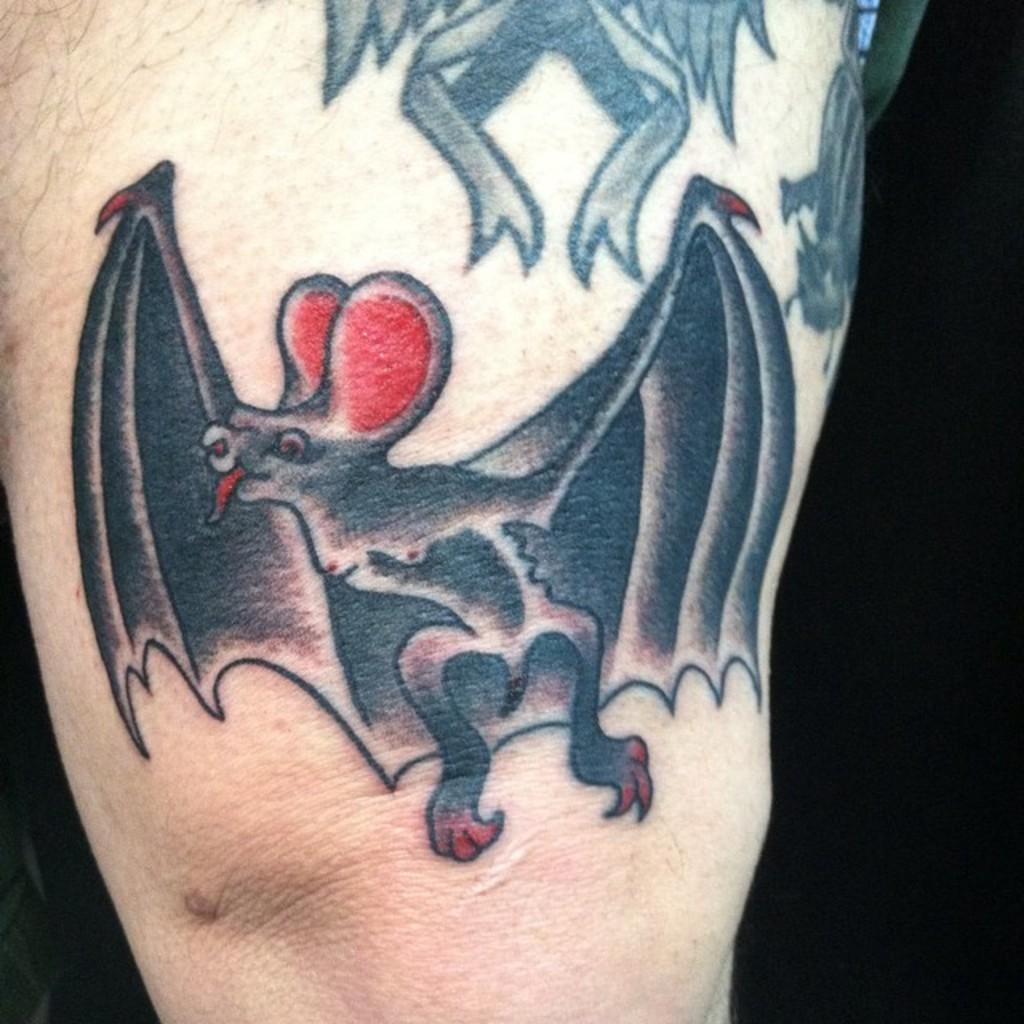What can be seen on the person's hand in the image? There is a tattoo on a person's hand in the image. What song is being sung by the person in the image? There is no indication of a song being sung in the image; the focus is on the tattoo on the person's hand. 